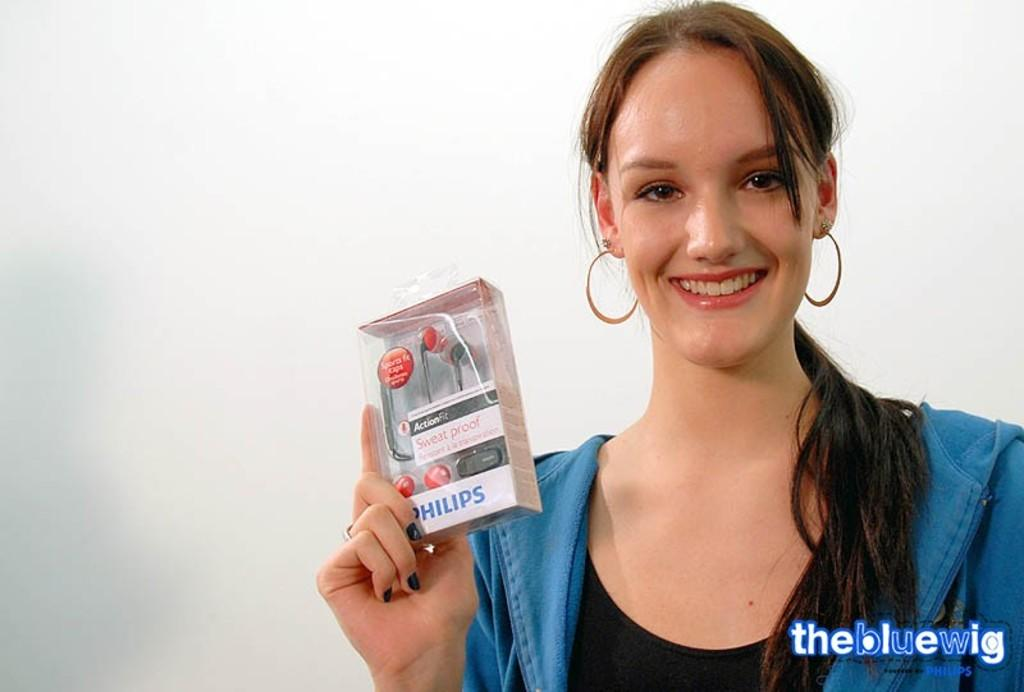Who is the main subject in the image? There is a girl in the image. What is the girl doing in the image? The girl is standing and smiling. What is the girl holding in her hands? The girl is holding a headset box in her hands. Can you describe any additional features of the image? There is a watermark at the bottom of the image. How many sheep can be seen in the image? There are no sheep present in the image. What type of snake is wrapped around the headset box? There is no snake present in the image. 